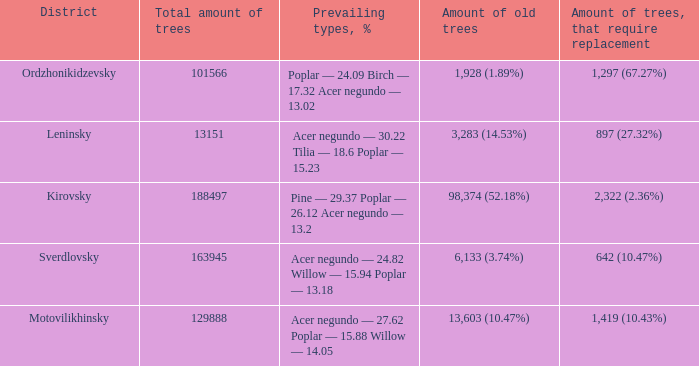What is the amount of trees, that require replacement when district is leninsky? 897 (27.32%). 